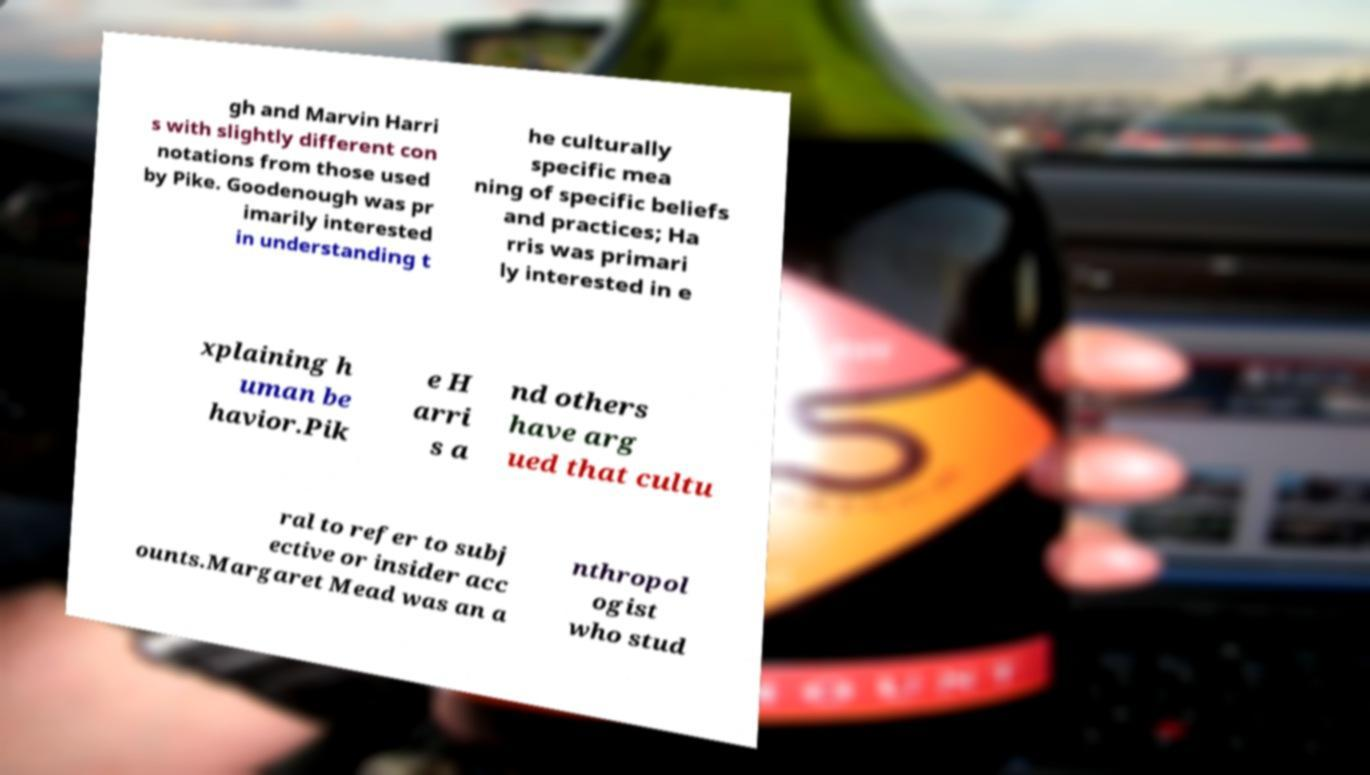Could you assist in decoding the text presented in this image and type it out clearly? gh and Marvin Harri s with slightly different con notations from those used by Pike. Goodenough was pr imarily interested in understanding t he culturally specific mea ning of specific beliefs and practices; Ha rris was primari ly interested in e xplaining h uman be havior.Pik e H arri s a nd others have arg ued that cultu ral to refer to subj ective or insider acc ounts.Margaret Mead was an a nthropol ogist who stud 